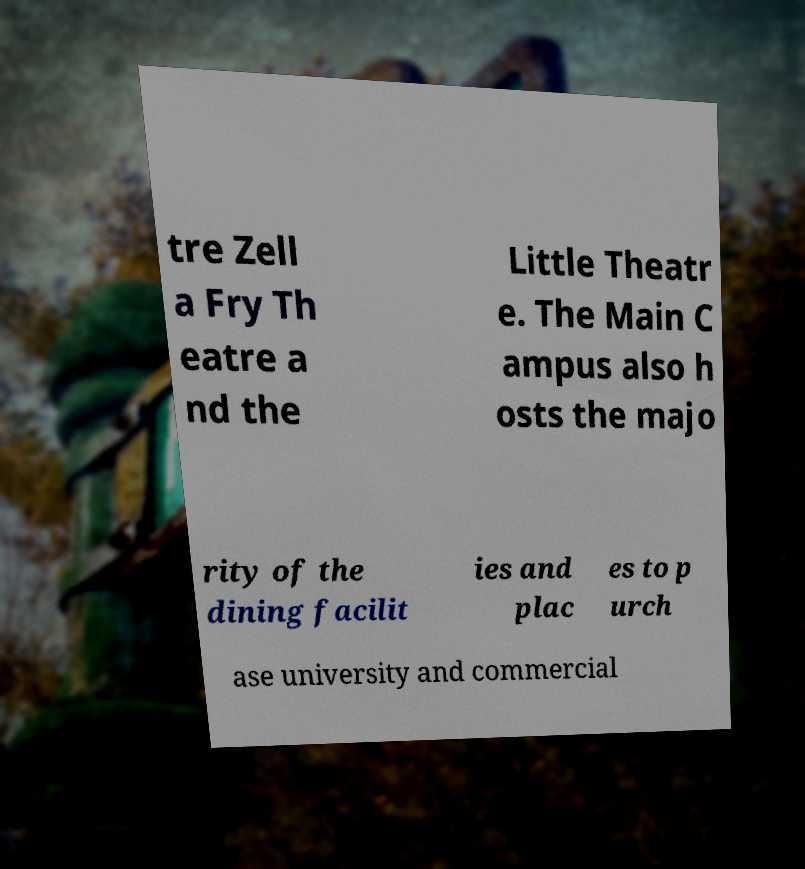For documentation purposes, I need the text within this image transcribed. Could you provide that? tre Zell a Fry Th eatre a nd the Little Theatr e. The Main C ampus also h osts the majo rity of the dining facilit ies and plac es to p urch ase university and commercial 